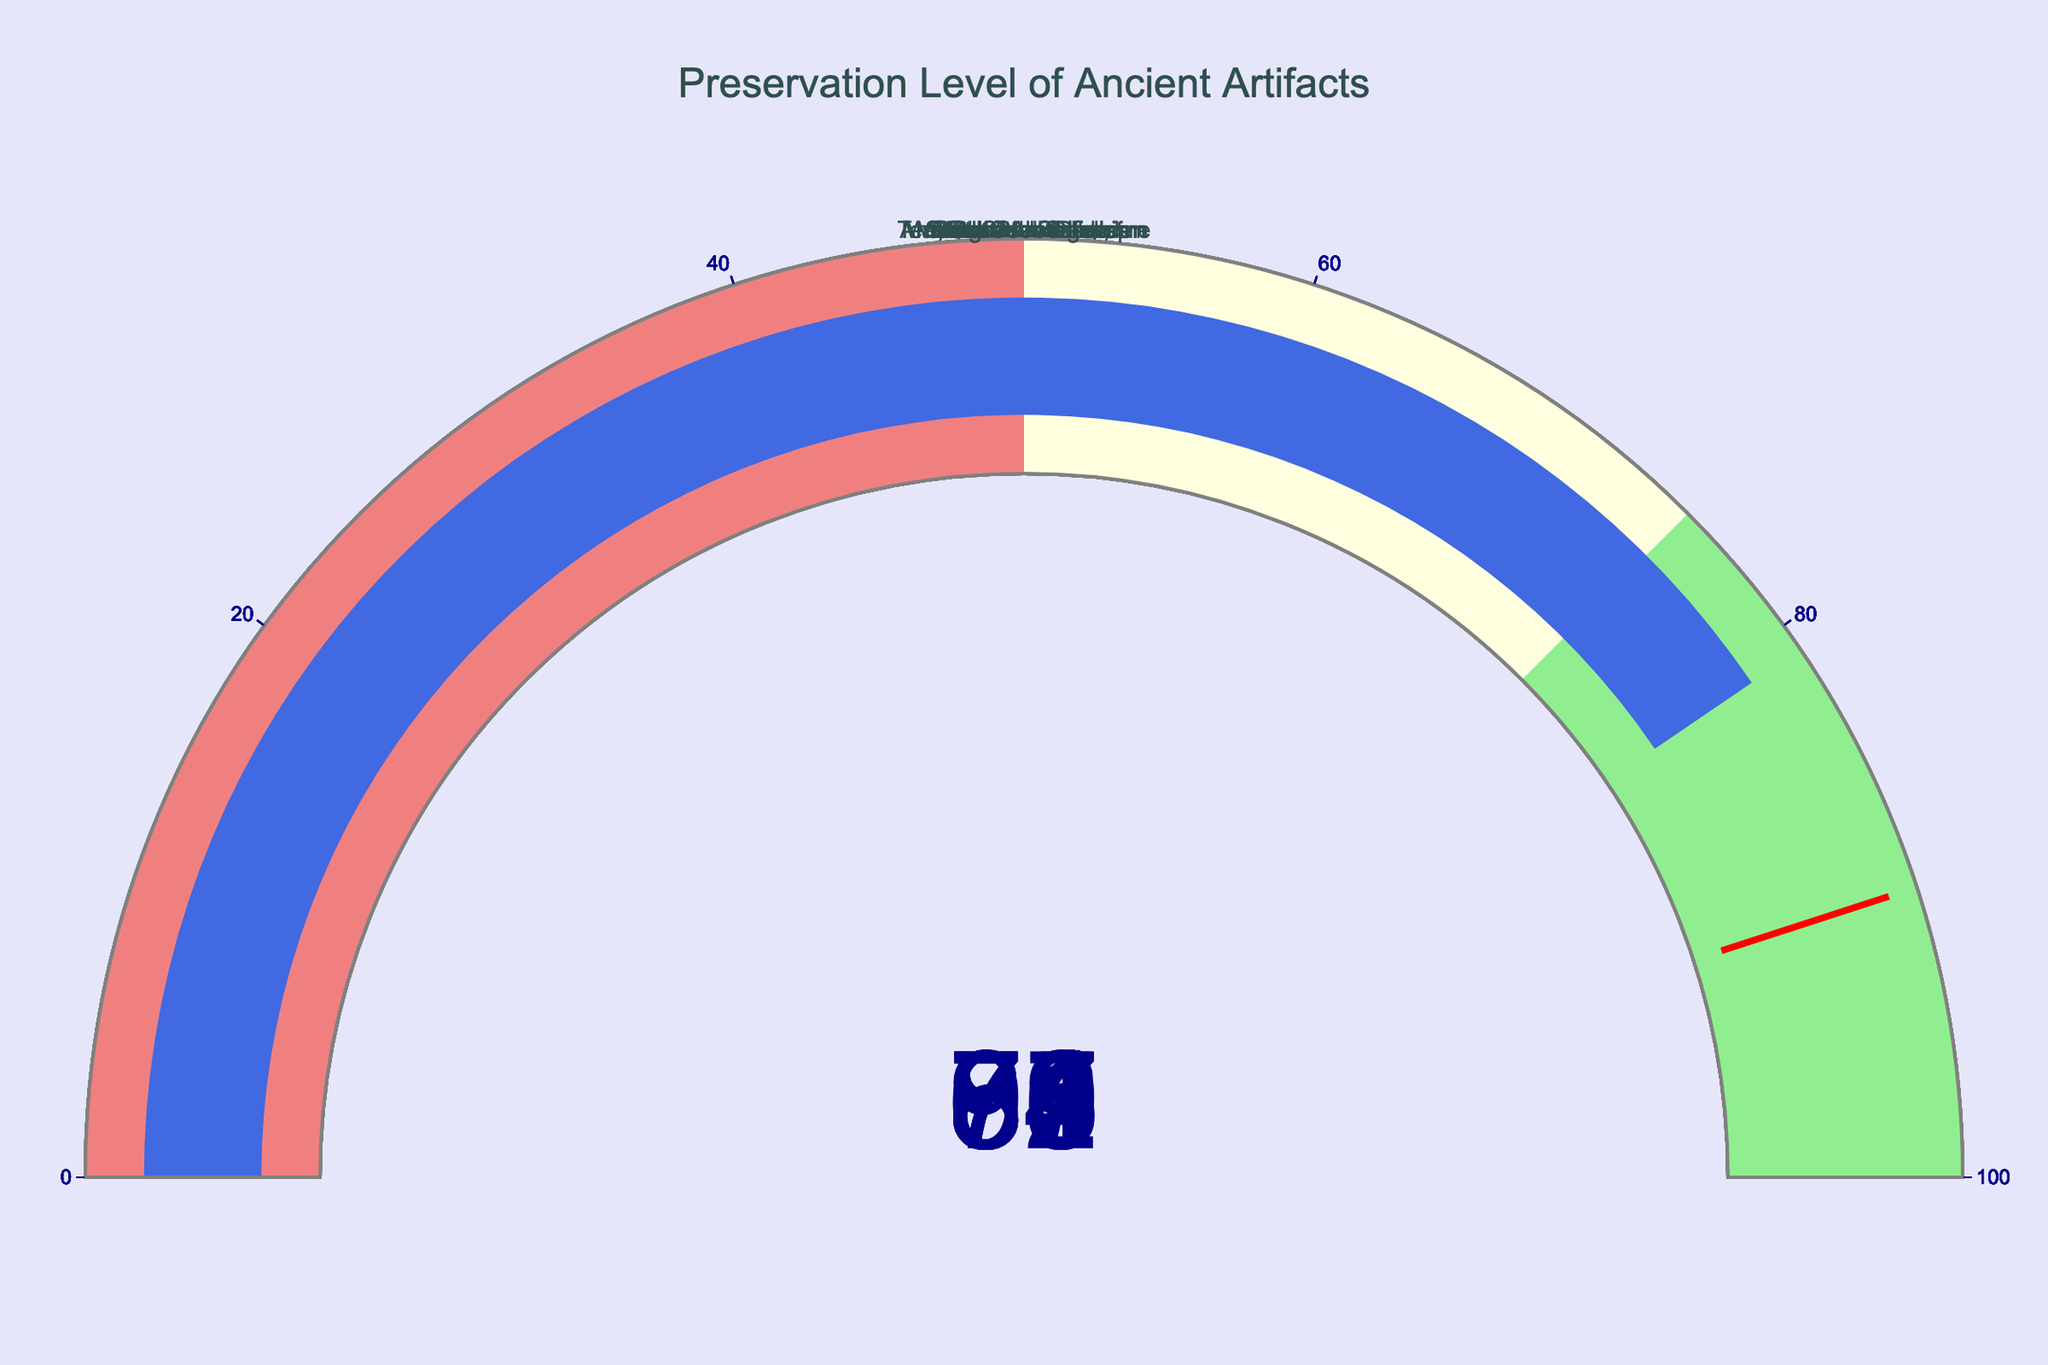What is the title of the chart? The title of the chart is displayed at the top of the figure. It reads "Preservation Level of Ancient Artifacts."
Answer: Preservation Level of Ancient Artifacts How many artifacts are shown in the figure? The chart displays a gauge for each artifact. By counting the gauges, we see there are ten artifacts in the figure.
Answer: 10 Which artifact has the highest preservation level? By looking at the highest value on the gauges, we see that the Rosetta Stone has the highest preservation level of 92.
Answer: Rosetta Stone What is the preservation level of the Antikythera mechanism? The preservation level of the Antikythera mechanism is shown on its respective gauge. It reads 71.
Answer: 71 Which artifacts have a preservation level above 80? Examining the gauges, the artifacts with preservation levels above 80 are: Rosetta Stone (92), Dead Sea Scrolls (87), Sutton Hoo helmet (85), Nebra sky disk (83), and Viking Oseberg ship (81).
Answer: Rosetta Stone, Dead Sea Scrolls, Sutton Hoo helmet, Nebra sky disk, Viking Oseberg ship What is the average preservation level of all artifacts? Sum the preservation levels and divide by the number of artifacts. (92 + 87 + 79 + 85 + 71 + 68 + 83 + 64 + 76 + 81) / 10 = 78.6
Answer: 78.6 How many artifacts fall into the "lightgreen" preservation level range (75-100)? Lightgreen ranges from 75 to 100. By counting the artifacts within this range, we get Rosetta Stone (92), Dead Sea Scrolls (87), Sutton Hoo helmet (85), Terracotta Army figurine (79), Nebra sky disk (83), and Viking Oseberg ship (81), making 6 artifacts.
Answer: 6 What is the difference in preservation level between the Rosetta Stone and the Mayan Codex Dresden? Subtract the Mayan Codex Dresden preservation level from the Rosetta Stone: 92 - 68 = 24
Answer: 24 Which artifact has the lowest preservation level? By identifying the gauge with the lowest number, we see that the Baghdad Battery has the lowest preservation level of 64.
Answer: Baghdad Battery Is there any artifact with a preservation level exactly at the threshold value of 90? By examining the gauges, none of the artifacts have a preservation level set exactly at 90.
Answer: No 